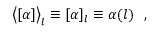<formula> <loc_0><loc_0><loc_500><loc_500>\left < [ \alpha ] \right > _ { l } \equiv [ \alpha ] _ { l } \equiv \alpha ( l ) ,</formula> 